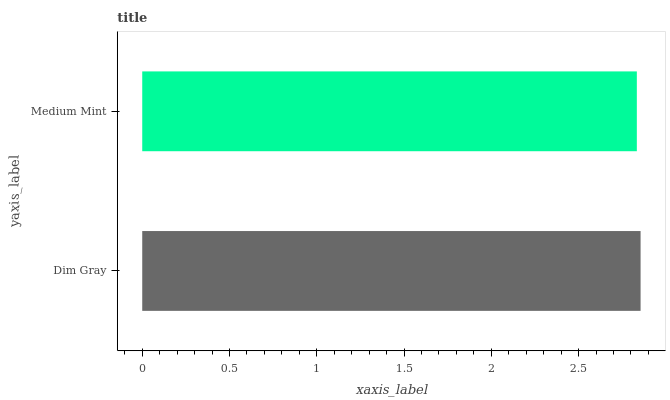Is Medium Mint the minimum?
Answer yes or no. Yes. Is Dim Gray the maximum?
Answer yes or no. Yes. Is Medium Mint the maximum?
Answer yes or no. No. Is Dim Gray greater than Medium Mint?
Answer yes or no. Yes. Is Medium Mint less than Dim Gray?
Answer yes or no. Yes. Is Medium Mint greater than Dim Gray?
Answer yes or no. No. Is Dim Gray less than Medium Mint?
Answer yes or no. No. Is Dim Gray the high median?
Answer yes or no. Yes. Is Medium Mint the low median?
Answer yes or no. Yes. Is Medium Mint the high median?
Answer yes or no. No. Is Dim Gray the low median?
Answer yes or no. No. 